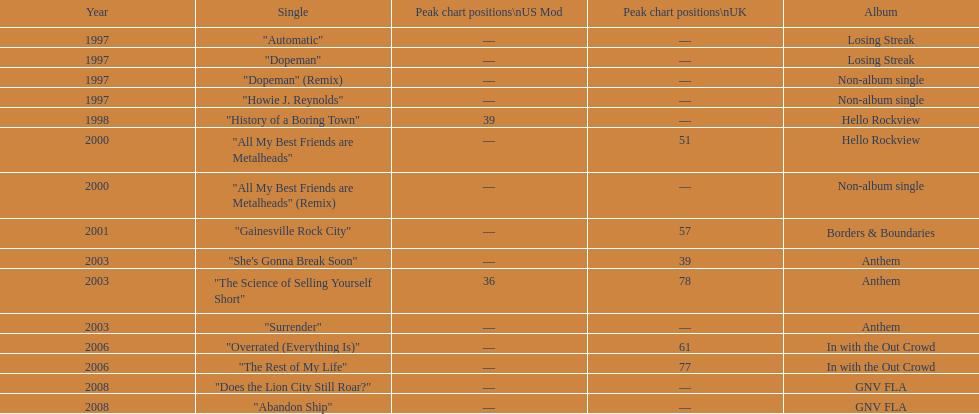Which song came out first? dopeman or surrender. Dopeman. 